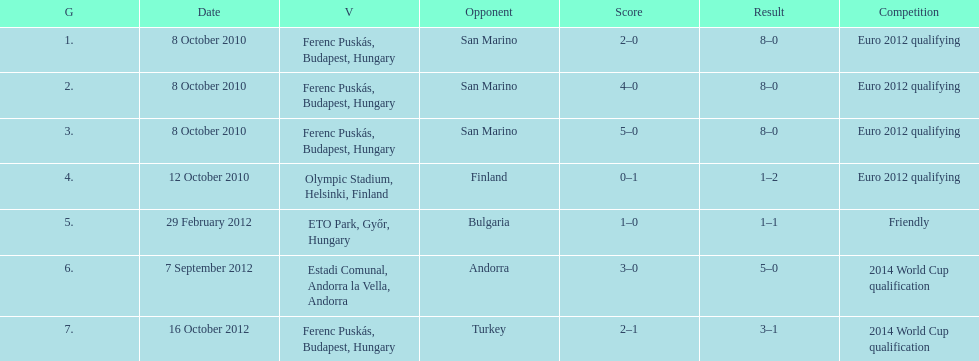In what year was szalai's first international goal? 2010. 